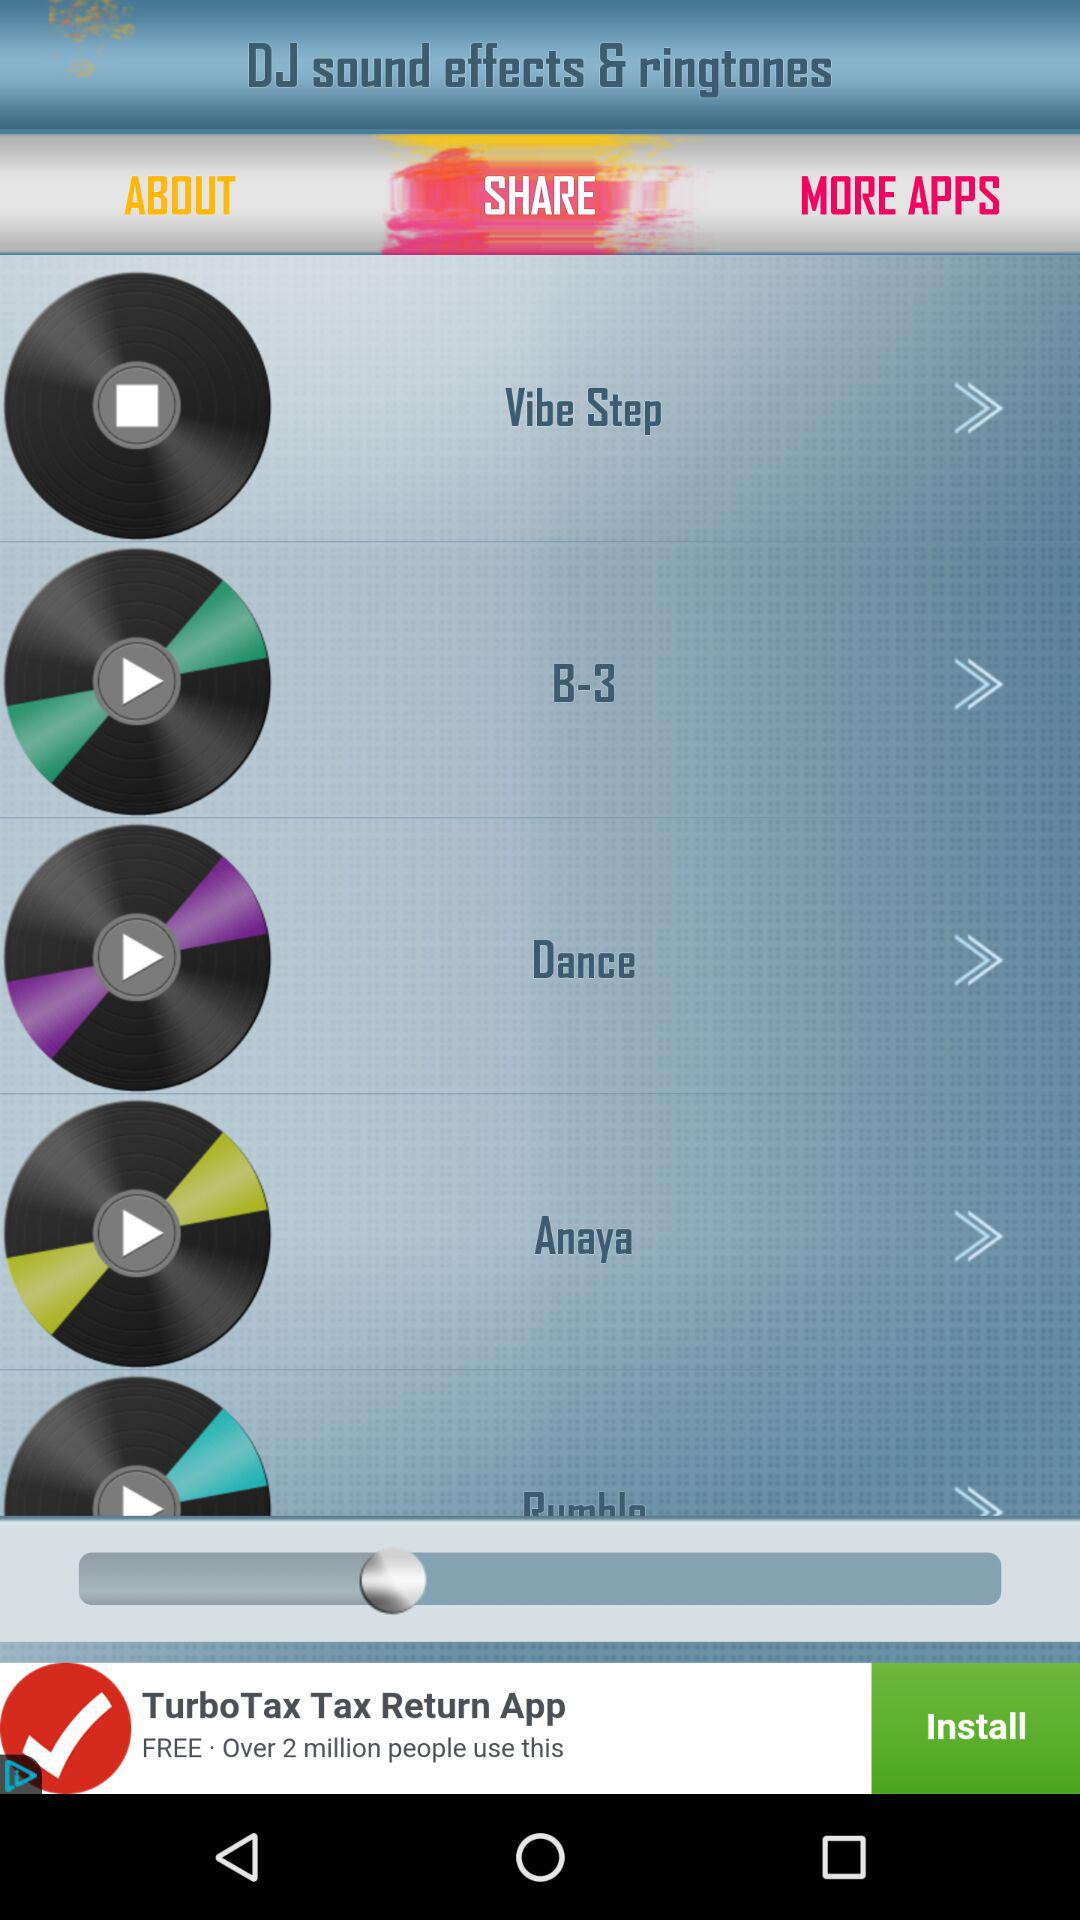What is the application name? The application name is "DJ sound effects & ringtones". 